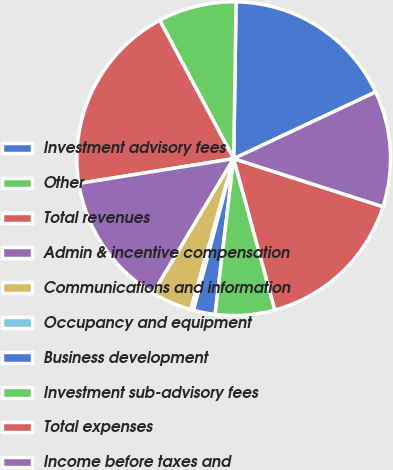Convert chart to OTSL. <chart><loc_0><loc_0><loc_500><loc_500><pie_chart><fcel>Investment advisory fees<fcel>Other<fcel>Total revenues<fcel>Admin & incentive compensation<fcel>Communications and information<fcel>Occupancy and equipment<fcel>Business development<fcel>Investment sub-advisory fees<fcel>Total expenses<fcel>Income before taxes and<nl><fcel>17.77%<fcel>8.06%<fcel>19.71%<fcel>13.88%<fcel>4.18%<fcel>0.29%<fcel>2.23%<fcel>6.12%<fcel>15.82%<fcel>11.94%<nl></chart> 